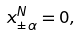Convert formula to latex. <formula><loc_0><loc_0><loc_500><loc_500>x _ { \pm \alpha } ^ { N } = 0 ,</formula> 